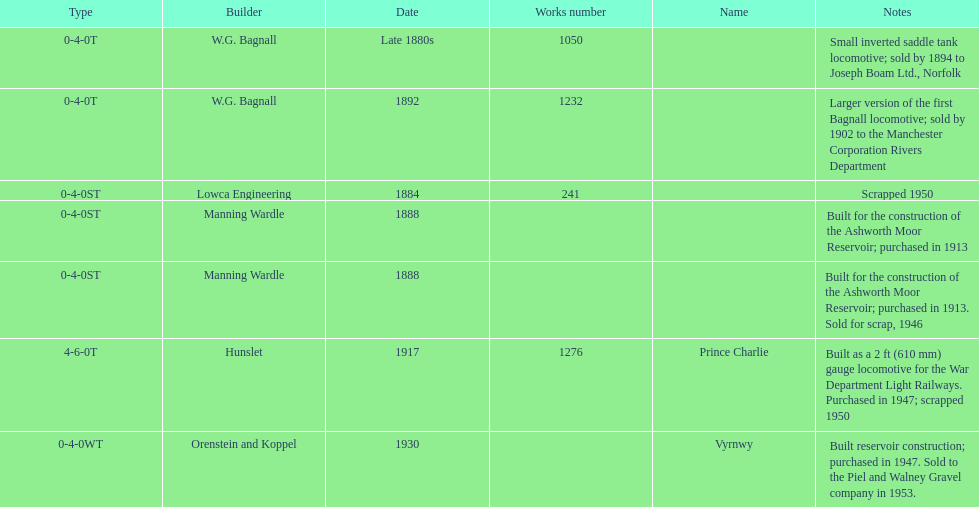List each of the builder's that had a locomotive scrapped. Lowca Engineering, Manning Wardle, Hunslet. 